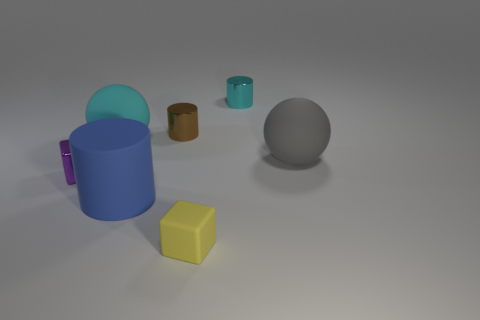Add 2 yellow rubber objects. How many objects exist? 9 Subtract all spheres. How many objects are left? 5 Add 3 tiny purple blocks. How many tiny purple blocks are left? 4 Add 1 big blue matte cylinders. How many big blue matte cylinders exist? 2 Subtract 0 brown spheres. How many objects are left? 7 Subtract all rubber blocks. Subtract all small brown shiny cylinders. How many objects are left? 5 